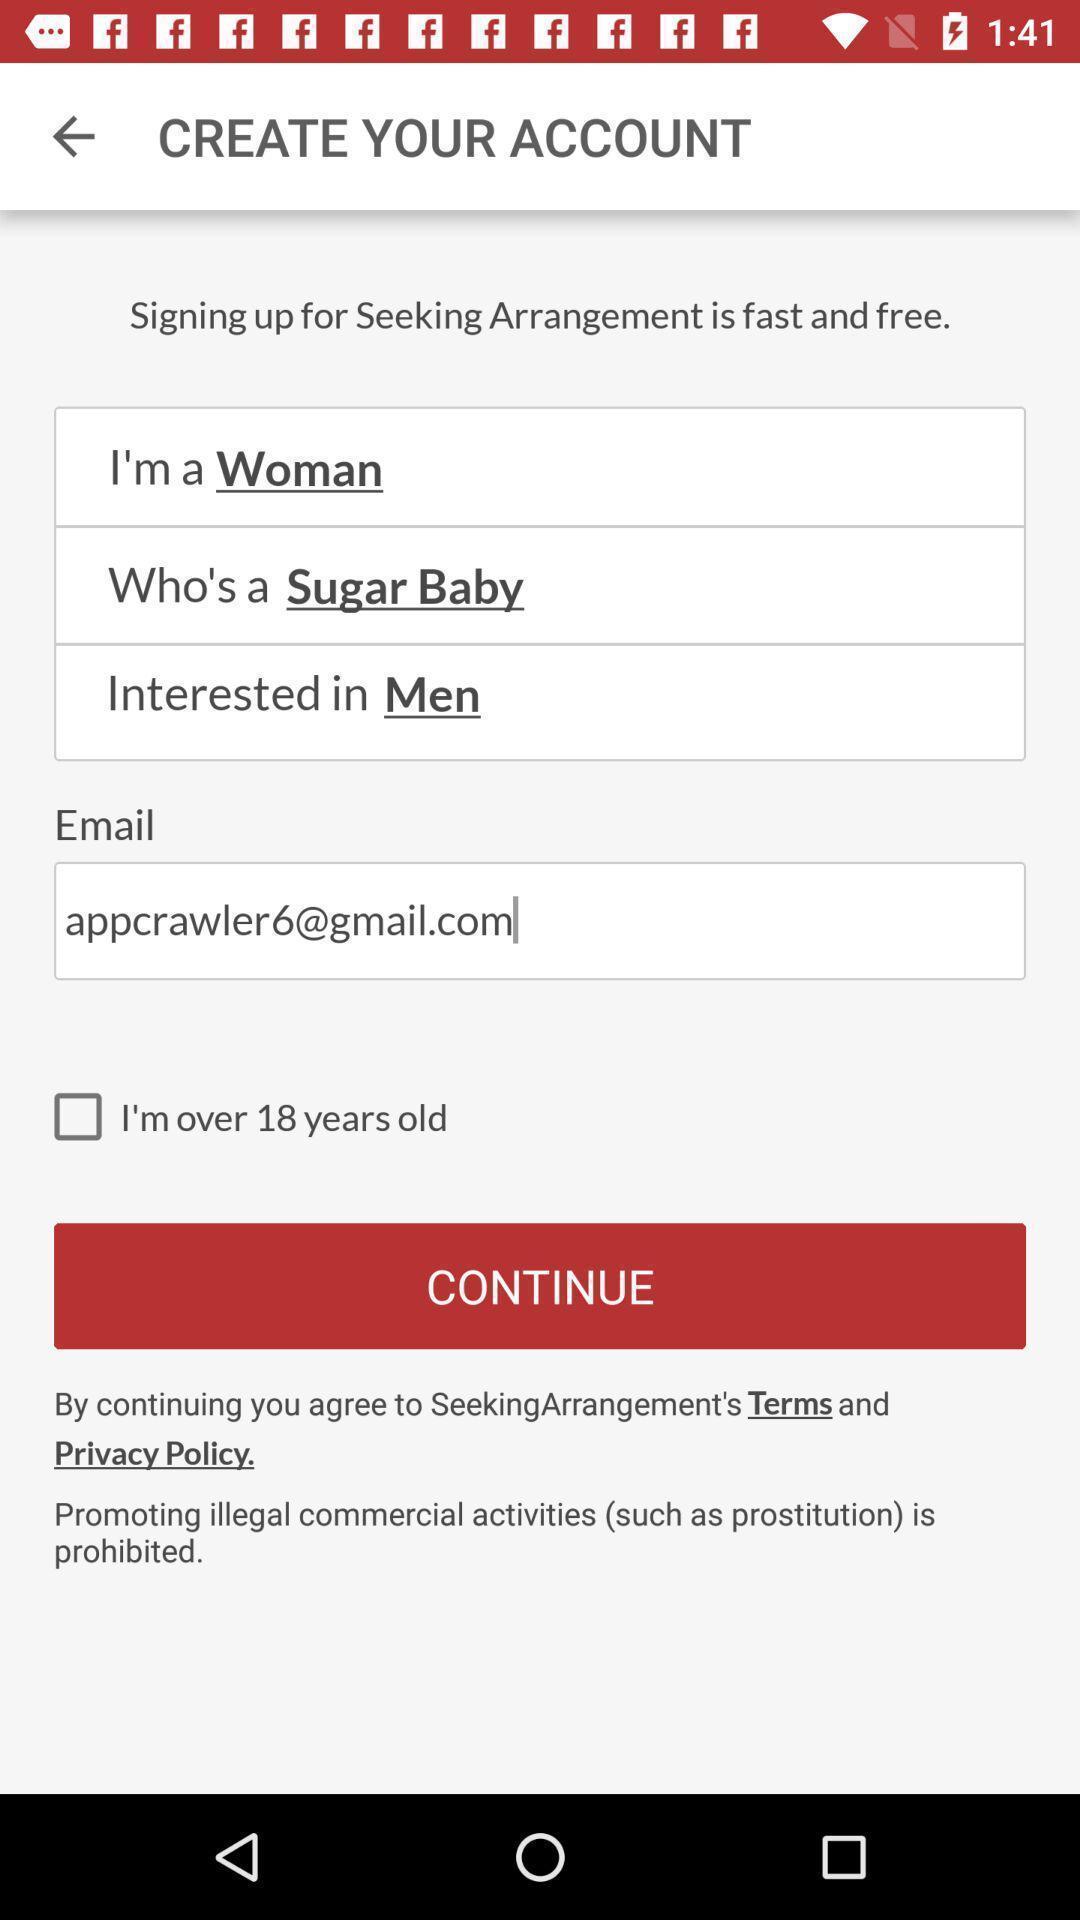Explain the elements present in this screenshot. Screen displaying the options to create account. 